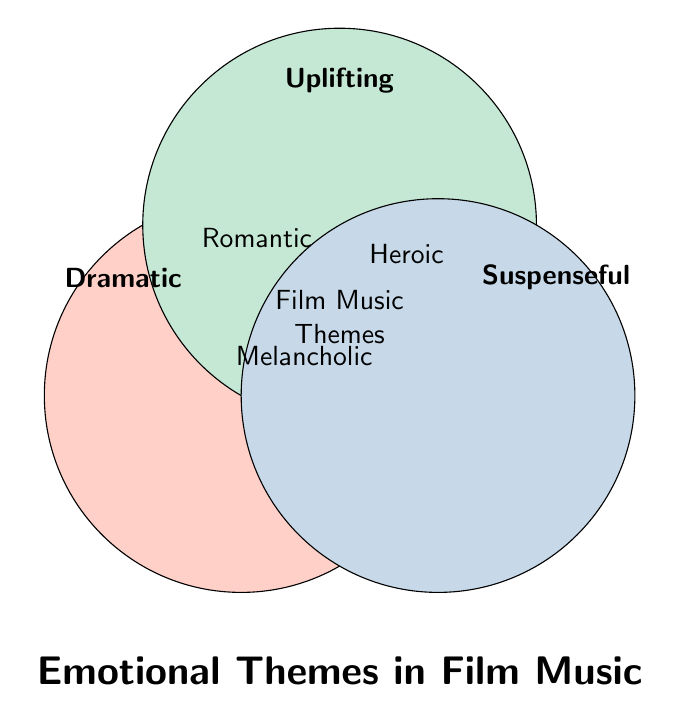What are the main emotional themes in the Venn diagram? The three main circles are labeled as Dramatic, Uplifting, and Suspenseful, indicating that these are the main emotional themes.
Answer: Dramatic, Uplifting, Suspenseful Which emotional theme intersects with all three main circles? At the intersection of all three main circles, the term "Film Music Themes" is located, indicating it represents the collective intersection.
Answer: Film Music Themes How many emotional themes are at the intersection of Dramatic and Uplifting? In the overlapping area between the Dramatic and Uplifting circles, the theme "Romantic" is placed, so there is 1 theme.
Answer: 1 Which emotional themes are found at the intersection of Uplifting and Suspenseful? In the area where the Uplifting and Suspenseful circles overlap, the theme "Heroic" is located.
Answer: Heroic What is the emotional theme found at the intersection of Dramatic and Suspenseful? In the overlapping area between the Dramatic and Suspenseful circles, the theme "Melancholic" is present.
Answer: Melancholic Is there any emotional theme that intersects both Dramatic and Suspenseful but not Uplifting? Yes, the "Melancholic" theme is in the intersection of Dramatic and Suspenseful but does not overlap with Uplifting.
Answer: Yes, Melancholic Which intersection has the most emotional themes listed? Each intersection (Dramatic+Uplifting, Dramatic+Suspenseful, Uplifting+Suspenseful) has one theme, so all intersections have the same number of themes.
Answer: All intersections have the same Are there any emotional themes that only belong to the Uplifting category? The Venn diagram does not show any themes that belong exclusively to the Uplifting category; all intersect with other themes.
Answer: No Which themes are shared by exactly two emotional categories? Romantic (Dramatic and Uplifting), Melancholic (Dramatic and Suspenseful), Heroic (Uplifting and Suspenseful) are the themes shared by exactly two categories.
Answer: Romantic, Melancholic, Heroic 